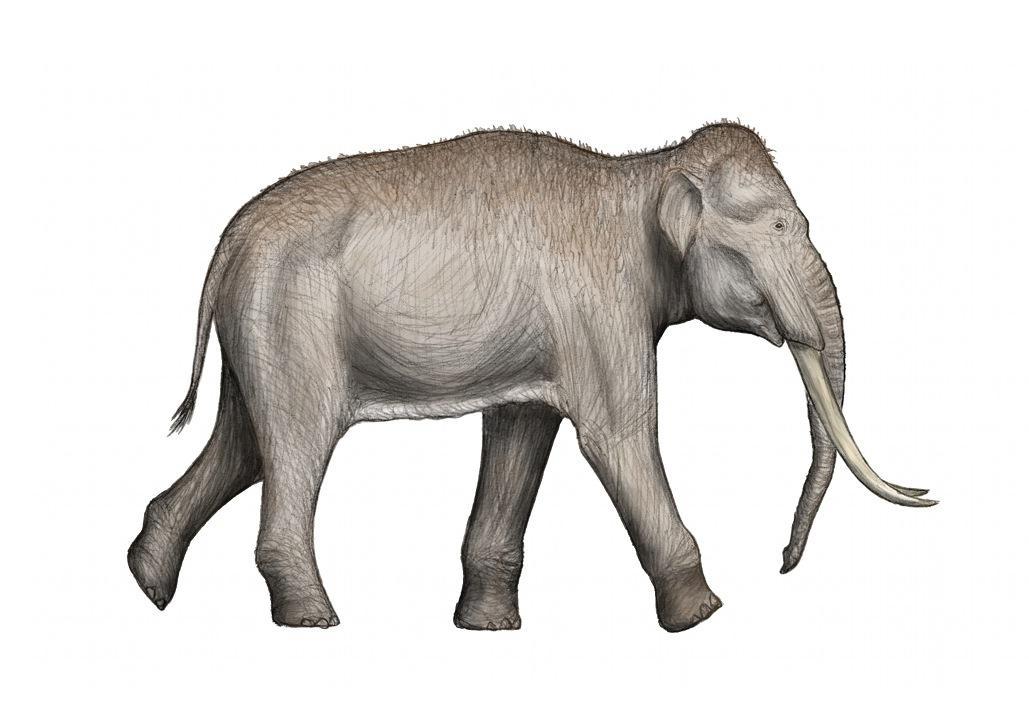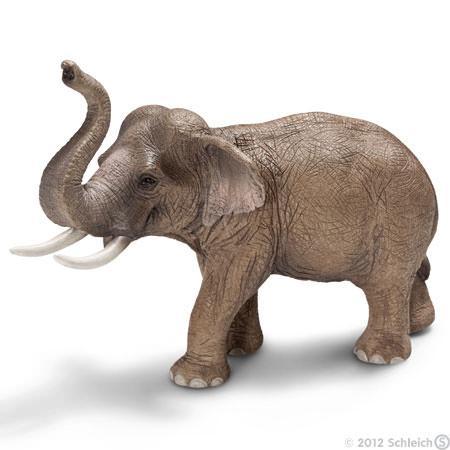The first image is the image on the left, the second image is the image on the right. For the images shown, is this caption "There is exactly one elephant facing left and exactly one elephant facing right." true? Answer yes or no. Yes. 